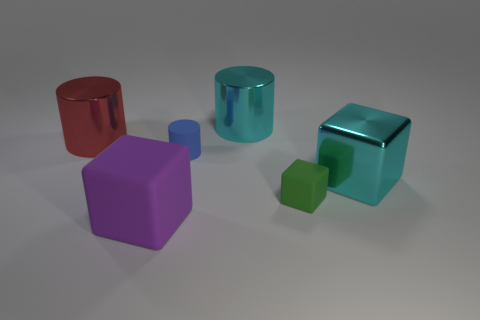Add 2 small green metallic spheres. How many objects exist? 8 Add 3 big metallic cubes. How many big metallic cubes are left? 4 Add 6 big green metallic blocks. How many big green metallic blocks exist? 6 Subtract 0 blue cubes. How many objects are left? 6 Subtract all large metal things. Subtract all big red objects. How many objects are left? 2 